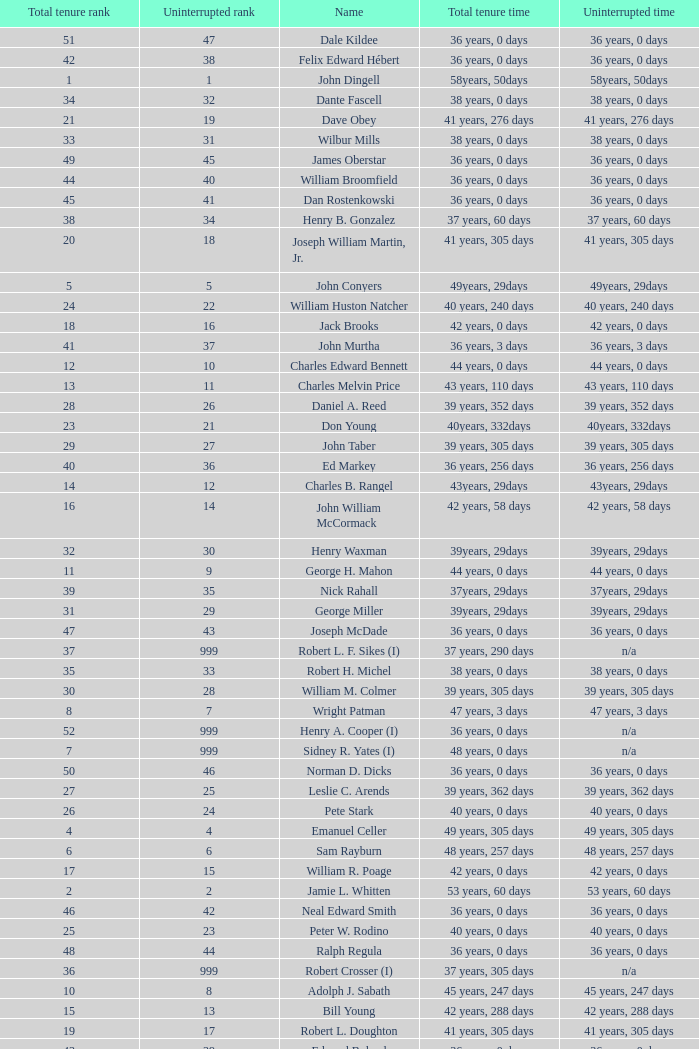Who has a total tenure time and uninterrupted time of 36 years, 0 days, as well as a total tenure rank of 49? James Oberstar. 